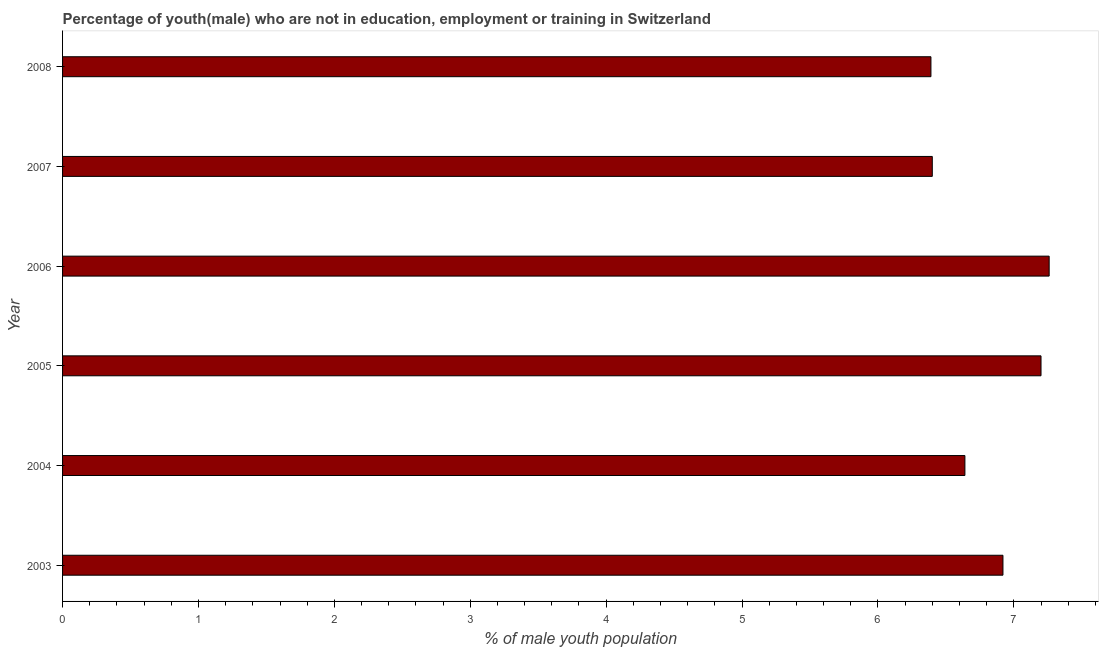Does the graph contain any zero values?
Keep it short and to the point. No. What is the title of the graph?
Ensure brevity in your answer.  Percentage of youth(male) who are not in education, employment or training in Switzerland. What is the label or title of the X-axis?
Provide a succinct answer. % of male youth population. What is the unemployed male youth population in 2006?
Your answer should be compact. 7.26. Across all years, what is the maximum unemployed male youth population?
Make the answer very short. 7.26. Across all years, what is the minimum unemployed male youth population?
Your answer should be compact. 6.39. In which year was the unemployed male youth population maximum?
Ensure brevity in your answer.  2006. In which year was the unemployed male youth population minimum?
Keep it short and to the point. 2008. What is the sum of the unemployed male youth population?
Offer a very short reply. 40.81. What is the difference between the unemployed male youth population in 2004 and 2007?
Offer a terse response. 0.24. What is the average unemployed male youth population per year?
Ensure brevity in your answer.  6.8. What is the median unemployed male youth population?
Offer a very short reply. 6.78. In how many years, is the unemployed male youth population greater than 6.8 %?
Offer a very short reply. 3. What is the ratio of the unemployed male youth population in 2005 to that in 2006?
Make the answer very short. 0.99. Is the difference between the unemployed male youth population in 2005 and 2007 greater than the difference between any two years?
Keep it short and to the point. No. What is the difference between the highest and the second highest unemployed male youth population?
Offer a terse response. 0.06. Is the sum of the unemployed male youth population in 2005 and 2008 greater than the maximum unemployed male youth population across all years?
Ensure brevity in your answer.  Yes. What is the difference between the highest and the lowest unemployed male youth population?
Your answer should be very brief. 0.87. How many bars are there?
Keep it short and to the point. 6. Are all the bars in the graph horizontal?
Make the answer very short. Yes. What is the % of male youth population in 2003?
Your answer should be very brief. 6.92. What is the % of male youth population in 2004?
Make the answer very short. 6.64. What is the % of male youth population of 2005?
Your response must be concise. 7.2. What is the % of male youth population in 2006?
Provide a succinct answer. 7.26. What is the % of male youth population of 2007?
Keep it short and to the point. 6.4. What is the % of male youth population in 2008?
Provide a succinct answer. 6.39. What is the difference between the % of male youth population in 2003 and 2004?
Offer a terse response. 0.28. What is the difference between the % of male youth population in 2003 and 2005?
Offer a terse response. -0.28. What is the difference between the % of male youth population in 2003 and 2006?
Your answer should be compact. -0.34. What is the difference between the % of male youth population in 2003 and 2007?
Your answer should be compact. 0.52. What is the difference between the % of male youth population in 2003 and 2008?
Offer a very short reply. 0.53. What is the difference between the % of male youth population in 2004 and 2005?
Provide a short and direct response. -0.56. What is the difference between the % of male youth population in 2004 and 2006?
Provide a succinct answer. -0.62. What is the difference between the % of male youth population in 2004 and 2007?
Your response must be concise. 0.24. What is the difference between the % of male youth population in 2004 and 2008?
Make the answer very short. 0.25. What is the difference between the % of male youth population in 2005 and 2006?
Your answer should be compact. -0.06. What is the difference between the % of male youth population in 2005 and 2007?
Your answer should be compact. 0.8. What is the difference between the % of male youth population in 2005 and 2008?
Make the answer very short. 0.81. What is the difference between the % of male youth population in 2006 and 2007?
Your response must be concise. 0.86. What is the difference between the % of male youth population in 2006 and 2008?
Ensure brevity in your answer.  0.87. What is the difference between the % of male youth population in 2007 and 2008?
Keep it short and to the point. 0.01. What is the ratio of the % of male youth population in 2003 to that in 2004?
Provide a succinct answer. 1.04. What is the ratio of the % of male youth population in 2003 to that in 2005?
Keep it short and to the point. 0.96. What is the ratio of the % of male youth population in 2003 to that in 2006?
Provide a succinct answer. 0.95. What is the ratio of the % of male youth population in 2003 to that in 2007?
Your answer should be compact. 1.08. What is the ratio of the % of male youth population in 2003 to that in 2008?
Make the answer very short. 1.08. What is the ratio of the % of male youth population in 2004 to that in 2005?
Give a very brief answer. 0.92. What is the ratio of the % of male youth population in 2004 to that in 2006?
Provide a short and direct response. 0.92. What is the ratio of the % of male youth population in 2004 to that in 2008?
Provide a succinct answer. 1.04. What is the ratio of the % of male youth population in 2005 to that in 2006?
Your answer should be compact. 0.99. What is the ratio of the % of male youth population in 2005 to that in 2007?
Your answer should be very brief. 1.12. What is the ratio of the % of male youth population in 2005 to that in 2008?
Offer a very short reply. 1.13. What is the ratio of the % of male youth population in 2006 to that in 2007?
Give a very brief answer. 1.13. What is the ratio of the % of male youth population in 2006 to that in 2008?
Your answer should be very brief. 1.14. What is the ratio of the % of male youth population in 2007 to that in 2008?
Offer a terse response. 1. 